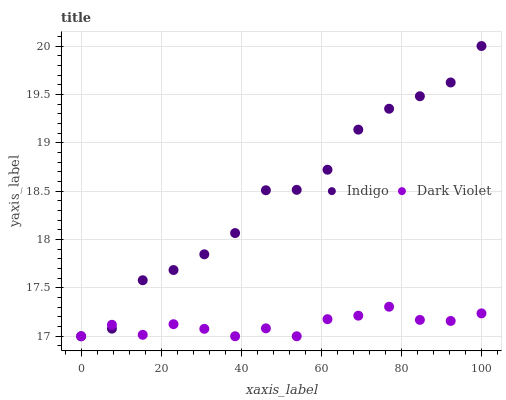Does Dark Violet have the minimum area under the curve?
Answer yes or no. Yes. Does Indigo have the maximum area under the curve?
Answer yes or no. Yes. Does Dark Violet have the maximum area under the curve?
Answer yes or no. No. Is Dark Violet the smoothest?
Answer yes or no. Yes. Is Indigo the roughest?
Answer yes or no. Yes. Is Dark Violet the roughest?
Answer yes or no. No. Does Indigo have the lowest value?
Answer yes or no. Yes. Does Indigo have the highest value?
Answer yes or no. Yes. Does Dark Violet have the highest value?
Answer yes or no. No. Does Indigo intersect Dark Violet?
Answer yes or no. Yes. Is Indigo less than Dark Violet?
Answer yes or no. No. Is Indigo greater than Dark Violet?
Answer yes or no. No. 